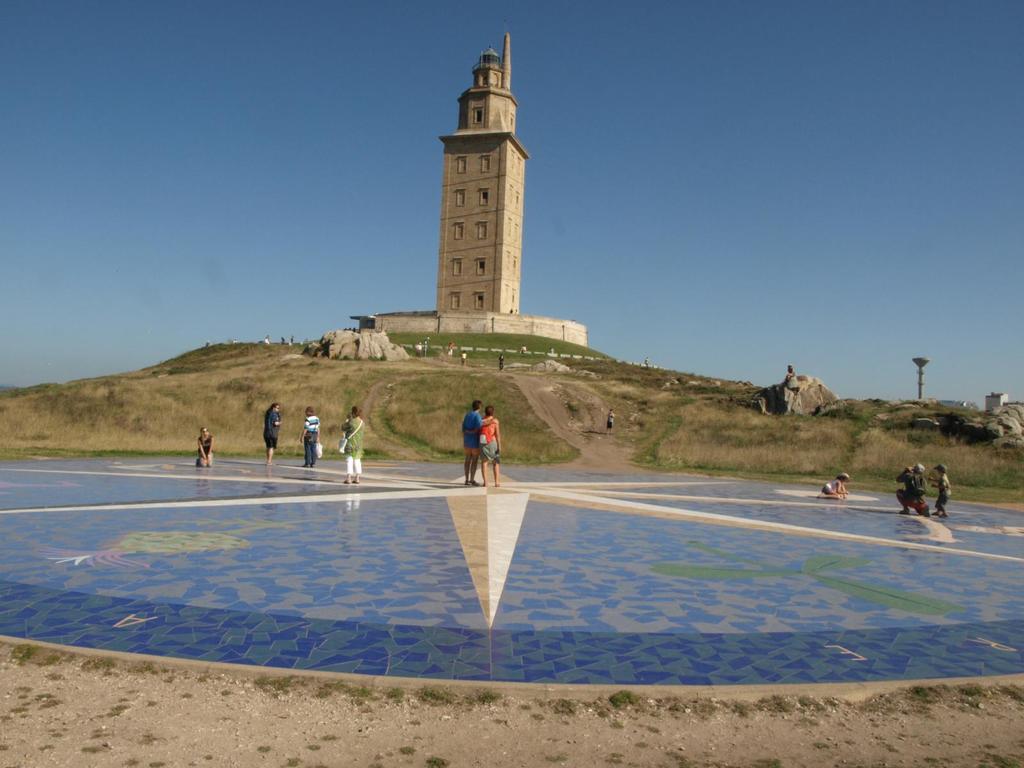Can you describe this image briefly? In this image there is a pillar on the hill, in front of the pillar there are some stones, persons visible on the floor, at the top there is the sky. On the floor there is a design. 